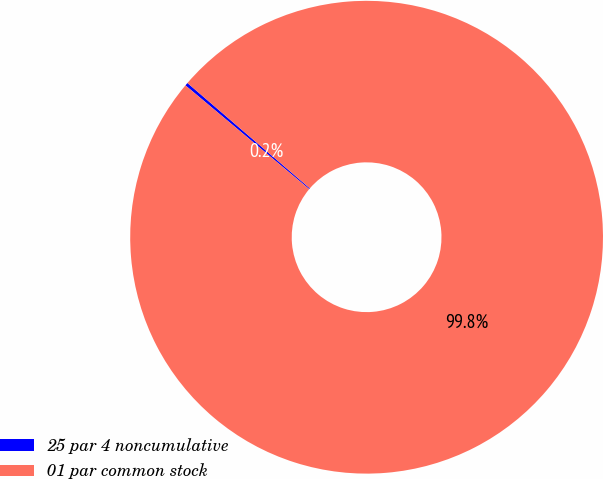<chart> <loc_0><loc_0><loc_500><loc_500><pie_chart><fcel>25 par 4 noncumulative<fcel>01 par common stock<nl><fcel>0.21%<fcel>99.79%<nl></chart> 